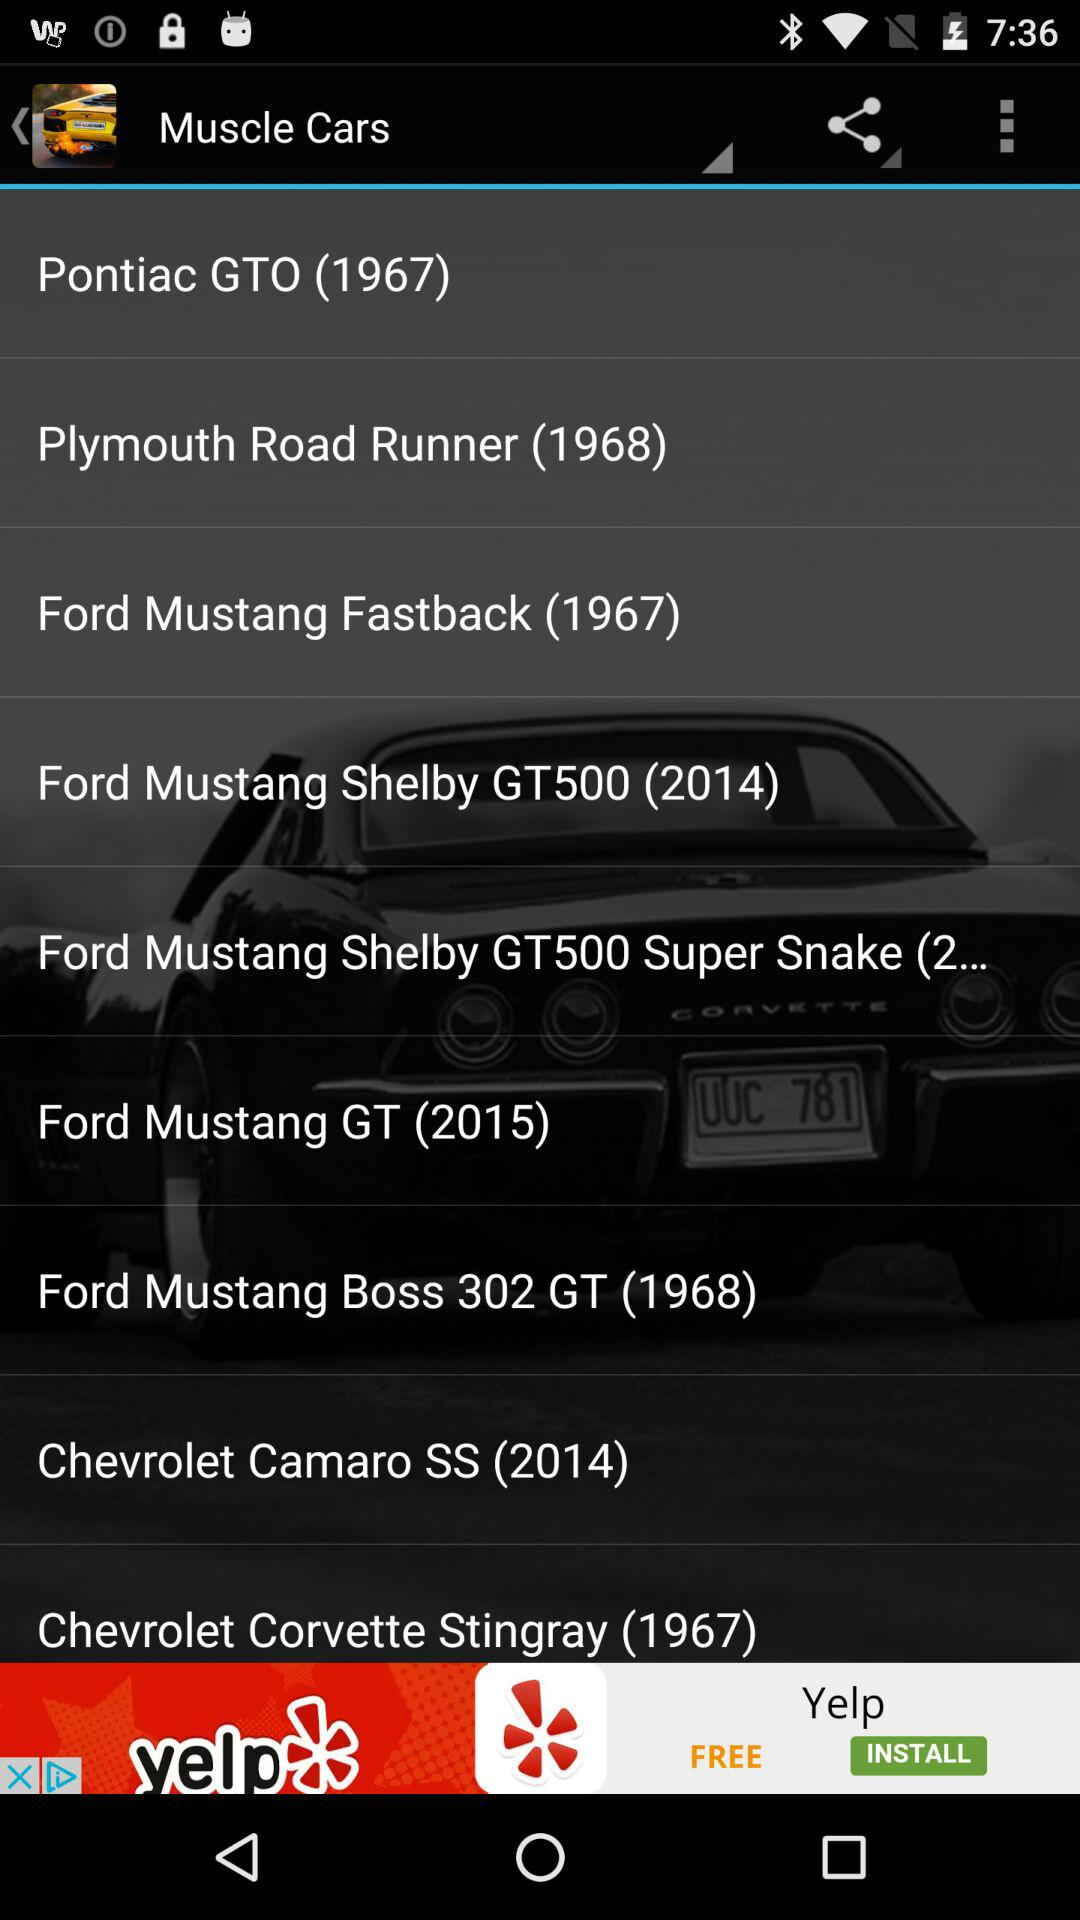What are the names of the different muscle cars? The names of the different muscle cars are "Pontiac GTO", "Plymouth Road Runner", "Ford Mustang Fastback", "Ford Mustang Shelby GT500", "Ford Mustang Shelby GT500 Super Snake (2... ", "Ford Mustang", "Ford Mustang Boss 302 GT", "Chevrolet Camaro SS" and "Chevrolet Corvette Stingray". 